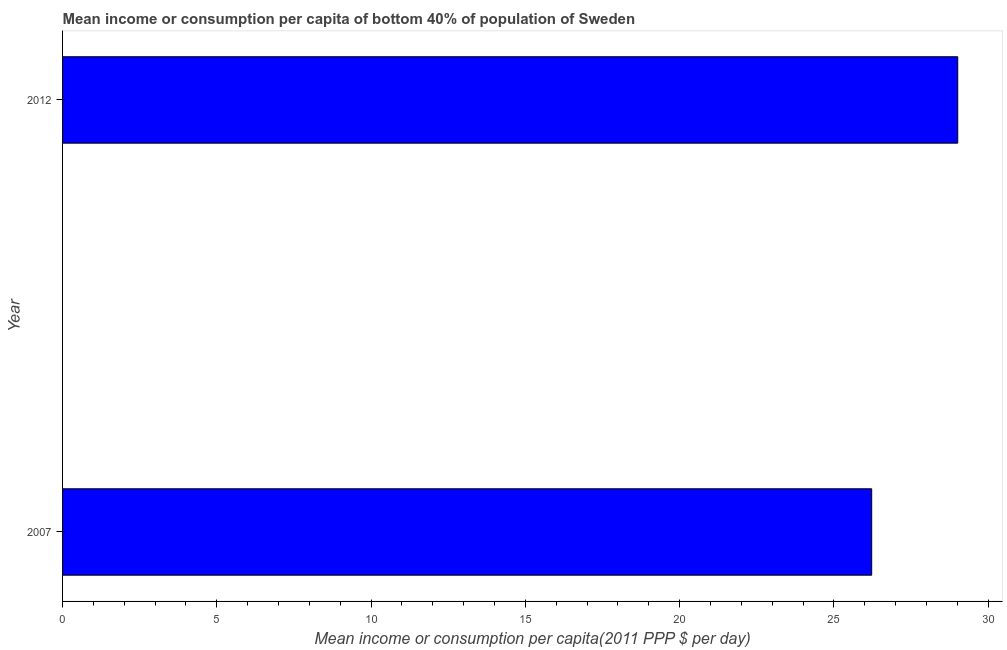Does the graph contain any zero values?
Your answer should be compact. No. Does the graph contain grids?
Make the answer very short. No. What is the title of the graph?
Make the answer very short. Mean income or consumption per capita of bottom 40% of population of Sweden. What is the label or title of the X-axis?
Your answer should be compact. Mean income or consumption per capita(2011 PPP $ per day). What is the label or title of the Y-axis?
Keep it short and to the point. Year. What is the mean income or consumption in 2007?
Ensure brevity in your answer.  26.22. Across all years, what is the maximum mean income or consumption?
Your answer should be compact. 29.01. Across all years, what is the minimum mean income or consumption?
Offer a very short reply. 26.22. In which year was the mean income or consumption minimum?
Your response must be concise. 2007. What is the sum of the mean income or consumption?
Your answer should be compact. 55.23. What is the difference between the mean income or consumption in 2007 and 2012?
Make the answer very short. -2.79. What is the average mean income or consumption per year?
Provide a short and direct response. 27.62. What is the median mean income or consumption?
Provide a short and direct response. 27.62. In how many years, is the mean income or consumption greater than 27 $?
Keep it short and to the point. 1. What is the ratio of the mean income or consumption in 2007 to that in 2012?
Give a very brief answer. 0.9. Is the mean income or consumption in 2007 less than that in 2012?
Your response must be concise. Yes. In how many years, is the mean income or consumption greater than the average mean income or consumption taken over all years?
Make the answer very short. 1. How many bars are there?
Make the answer very short. 2. What is the Mean income or consumption per capita(2011 PPP $ per day) in 2007?
Offer a terse response. 26.22. What is the Mean income or consumption per capita(2011 PPP $ per day) in 2012?
Offer a terse response. 29.01. What is the difference between the Mean income or consumption per capita(2011 PPP $ per day) in 2007 and 2012?
Your answer should be compact. -2.79. What is the ratio of the Mean income or consumption per capita(2011 PPP $ per day) in 2007 to that in 2012?
Ensure brevity in your answer.  0.9. 